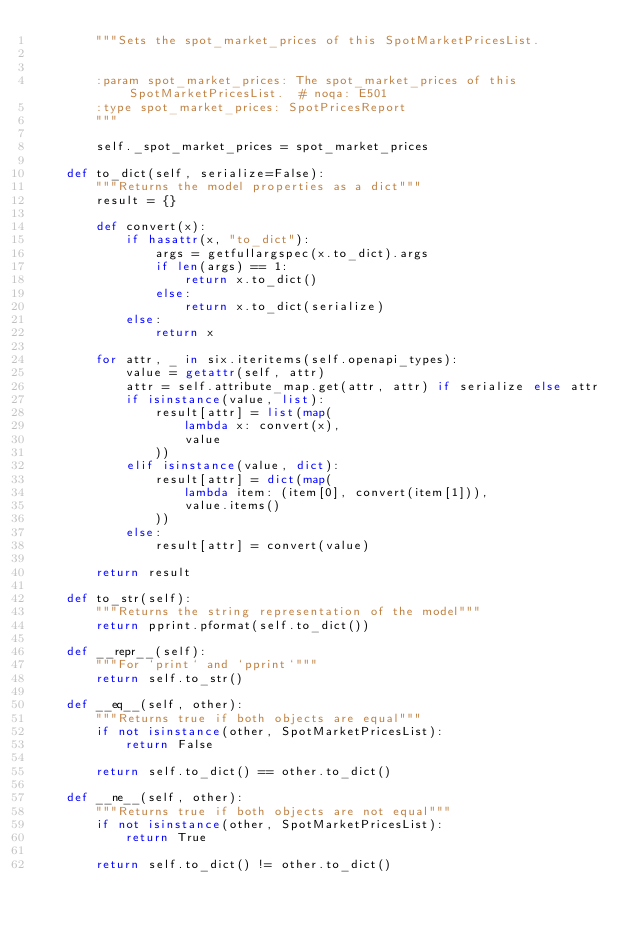Convert code to text. <code><loc_0><loc_0><loc_500><loc_500><_Python_>        """Sets the spot_market_prices of this SpotMarketPricesList.


        :param spot_market_prices: The spot_market_prices of this SpotMarketPricesList.  # noqa: E501
        :type spot_market_prices: SpotPricesReport
        """

        self._spot_market_prices = spot_market_prices

    def to_dict(self, serialize=False):
        """Returns the model properties as a dict"""
        result = {}

        def convert(x):
            if hasattr(x, "to_dict"):
                args = getfullargspec(x.to_dict).args
                if len(args) == 1:
                    return x.to_dict()
                else:
                    return x.to_dict(serialize)
            else:
                return x

        for attr, _ in six.iteritems(self.openapi_types):
            value = getattr(self, attr)
            attr = self.attribute_map.get(attr, attr) if serialize else attr
            if isinstance(value, list):
                result[attr] = list(map(
                    lambda x: convert(x),
                    value
                ))
            elif isinstance(value, dict):
                result[attr] = dict(map(
                    lambda item: (item[0], convert(item[1])),
                    value.items()
                ))
            else:
                result[attr] = convert(value)

        return result

    def to_str(self):
        """Returns the string representation of the model"""
        return pprint.pformat(self.to_dict())

    def __repr__(self):
        """For `print` and `pprint`"""
        return self.to_str()

    def __eq__(self, other):
        """Returns true if both objects are equal"""
        if not isinstance(other, SpotMarketPricesList):
            return False

        return self.to_dict() == other.to_dict()

    def __ne__(self, other):
        """Returns true if both objects are not equal"""
        if not isinstance(other, SpotMarketPricesList):
            return True

        return self.to_dict() != other.to_dict()
</code> 